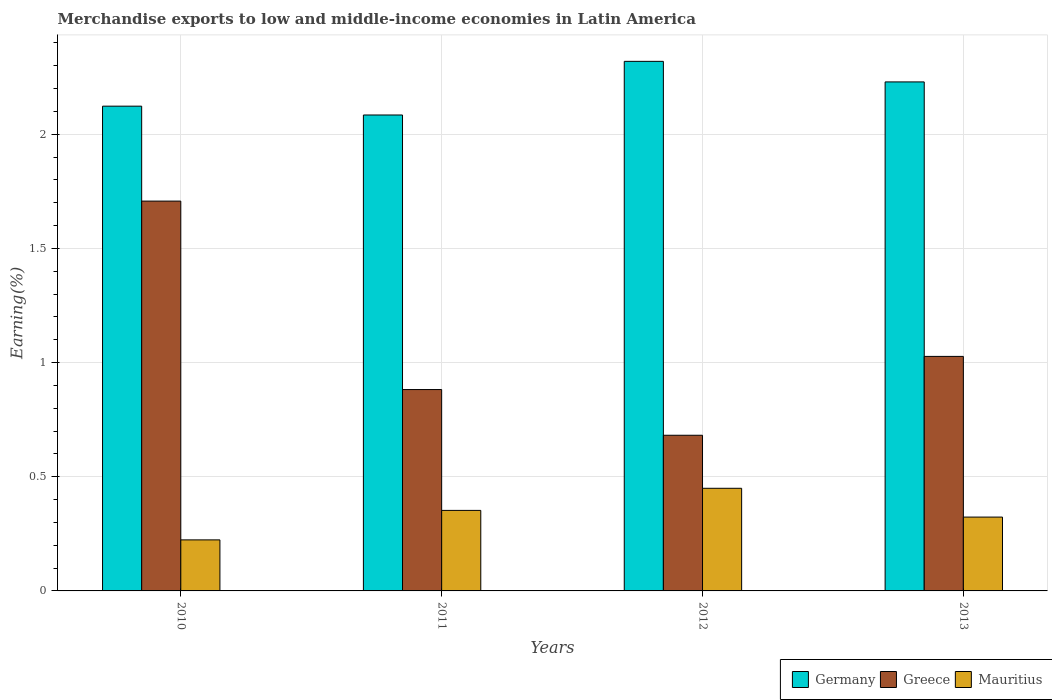How many different coloured bars are there?
Ensure brevity in your answer.  3. How many groups of bars are there?
Provide a succinct answer. 4. Are the number of bars on each tick of the X-axis equal?
Your answer should be compact. Yes. How many bars are there on the 2nd tick from the left?
Your answer should be compact. 3. In how many cases, is the number of bars for a given year not equal to the number of legend labels?
Give a very brief answer. 0. What is the percentage of amount earned from merchandise exports in Mauritius in 2011?
Offer a very short reply. 0.35. Across all years, what is the maximum percentage of amount earned from merchandise exports in Greece?
Offer a terse response. 1.71. Across all years, what is the minimum percentage of amount earned from merchandise exports in Mauritius?
Make the answer very short. 0.22. In which year was the percentage of amount earned from merchandise exports in Germany maximum?
Provide a short and direct response. 2012. In which year was the percentage of amount earned from merchandise exports in Germany minimum?
Give a very brief answer. 2011. What is the total percentage of amount earned from merchandise exports in Greece in the graph?
Keep it short and to the point. 4.3. What is the difference between the percentage of amount earned from merchandise exports in Mauritius in 2010 and that in 2011?
Provide a short and direct response. -0.13. What is the difference between the percentage of amount earned from merchandise exports in Germany in 2010 and the percentage of amount earned from merchandise exports in Mauritius in 2012?
Ensure brevity in your answer.  1.67. What is the average percentage of amount earned from merchandise exports in Germany per year?
Ensure brevity in your answer.  2.19. In the year 2011, what is the difference between the percentage of amount earned from merchandise exports in Mauritius and percentage of amount earned from merchandise exports in Germany?
Your response must be concise. -1.73. In how many years, is the percentage of amount earned from merchandise exports in Mauritius greater than 1.6 %?
Offer a very short reply. 0. What is the ratio of the percentage of amount earned from merchandise exports in Greece in 2011 to that in 2012?
Provide a short and direct response. 1.29. Is the percentage of amount earned from merchandise exports in Germany in 2011 less than that in 2012?
Provide a succinct answer. Yes. Is the difference between the percentage of amount earned from merchandise exports in Mauritius in 2011 and 2013 greater than the difference between the percentage of amount earned from merchandise exports in Germany in 2011 and 2013?
Your answer should be compact. Yes. What is the difference between the highest and the second highest percentage of amount earned from merchandise exports in Mauritius?
Provide a short and direct response. 0.1. What is the difference between the highest and the lowest percentage of amount earned from merchandise exports in Germany?
Make the answer very short. 0.23. What does the 2nd bar from the left in 2012 represents?
Your response must be concise. Greece. What does the 1st bar from the right in 2011 represents?
Make the answer very short. Mauritius. Is it the case that in every year, the sum of the percentage of amount earned from merchandise exports in Greece and percentage of amount earned from merchandise exports in Germany is greater than the percentage of amount earned from merchandise exports in Mauritius?
Keep it short and to the point. Yes. Are the values on the major ticks of Y-axis written in scientific E-notation?
Offer a terse response. No. Does the graph contain any zero values?
Offer a terse response. No. Where does the legend appear in the graph?
Your response must be concise. Bottom right. What is the title of the graph?
Your answer should be very brief. Merchandise exports to low and middle-income economies in Latin America. What is the label or title of the X-axis?
Provide a succinct answer. Years. What is the label or title of the Y-axis?
Provide a succinct answer. Earning(%). What is the Earning(%) in Germany in 2010?
Give a very brief answer. 2.12. What is the Earning(%) in Greece in 2010?
Make the answer very short. 1.71. What is the Earning(%) of Mauritius in 2010?
Your answer should be very brief. 0.22. What is the Earning(%) in Germany in 2011?
Your answer should be very brief. 2.08. What is the Earning(%) in Greece in 2011?
Provide a succinct answer. 0.88. What is the Earning(%) in Mauritius in 2011?
Your answer should be compact. 0.35. What is the Earning(%) in Germany in 2012?
Provide a short and direct response. 2.32. What is the Earning(%) in Greece in 2012?
Ensure brevity in your answer.  0.68. What is the Earning(%) in Mauritius in 2012?
Provide a succinct answer. 0.45. What is the Earning(%) of Germany in 2013?
Your answer should be compact. 2.23. What is the Earning(%) of Greece in 2013?
Provide a short and direct response. 1.03. What is the Earning(%) in Mauritius in 2013?
Provide a succinct answer. 0.32. Across all years, what is the maximum Earning(%) of Germany?
Offer a very short reply. 2.32. Across all years, what is the maximum Earning(%) in Greece?
Provide a short and direct response. 1.71. Across all years, what is the maximum Earning(%) in Mauritius?
Make the answer very short. 0.45. Across all years, what is the minimum Earning(%) of Germany?
Ensure brevity in your answer.  2.08. Across all years, what is the minimum Earning(%) in Greece?
Offer a terse response. 0.68. Across all years, what is the minimum Earning(%) of Mauritius?
Your answer should be very brief. 0.22. What is the total Earning(%) of Germany in the graph?
Keep it short and to the point. 8.75. What is the total Earning(%) of Greece in the graph?
Your answer should be very brief. 4.3. What is the total Earning(%) of Mauritius in the graph?
Your answer should be compact. 1.35. What is the difference between the Earning(%) of Germany in 2010 and that in 2011?
Make the answer very short. 0.04. What is the difference between the Earning(%) in Greece in 2010 and that in 2011?
Offer a very short reply. 0.83. What is the difference between the Earning(%) of Mauritius in 2010 and that in 2011?
Keep it short and to the point. -0.13. What is the difference between the Earning(%) of Germany in 2010 and that in 2012?
Your answer should be very brief. -0.2. What is the difference between the Earning(%) in Greece in 2010 and that in 2012?
Your response must be concise. 1.03. What is the difference between the Earning(%) in Mauritius in 2010 and that in 2012?
Your answer should be very brief. -0.23. What is the difference between the Earning(%) of Germany in 2010 and that in 2013?
Your answer should be very brief. -0.11. What is the difference between the Earning(%) in Greece in 2010 and that in 2013?
Your response must be concise. 0.68. What is the difference between the Earning(%) in Mauritius in 2010 and that in 2013?
Keep it short and to the point. -0.1. What is the difference between the Earning(%) in Germany in 2011 and that in 2012?
Ensure brevity in your answer.  -0.23. What is the difference between the Earning(%) in Greece in 2011 and that in 2012?
Offer a terse response. 0.2. What is the difference between the Earning(%) of Mauritius in 2011 and that in 2012?
Make the answer very short. -0.1. What is the difference between the Earning(%) in Germany in 2011 and that in 2013?
Your answer should be compact. -0.14. What is the difference between the Earning(%) of Greece in 2011 and that in 2013?
Offer a terse response. -0.15. What is the difference between the Earning(%) in Mauritius in 2011 and that in 2013?
Ensure brevity in your answer.  0.03. What is the difference between the Earning(%) in Germany in 2012 and that in 2013?
Offer a terse response. 0.09. What is the difference between the Earning(%) of Greece in 2012 and that in 2013?
Give a very brief answer. -0.35. What is the difference between the Earning(%) in Mauritius in 2012 and that in 2013?
Provide a succinct answer. 0.13. What is the difference between the Earning(%) of Germany in 2010 and the Earning(%) of Greece in 2011?
Provide a succinct answer. 1.24. What is the difference between the Earning(%) of Germany in 2010 and the Earning(%) of Mauritius in 2011?
Offer a terse response. 1.77. What is the difference between the Earning(%) in Greece in 2010 and the Earning(%) in Mauritius in 2011?
Provide a succinct answer. 1.35. What is the difference between the Earning(%) in Germany in 2010 and the Earning(%) in Greece in 2012?
Provide a succinct answer. 1.44. What is the difference between the Earning(%) of Germany in 2010 and the Earning(%) of Mauritius in 2012?
Provide a short and direct response. 1.67. What is the difference between the Earning(%) of Greece in 2010 and the Earning(%) of Mauritius in 2012?
Your answer should be compact. 1.26. What is the difference between the Earning(%) in Germany in 2010 and the Earning(%) in Greece in 2013?
Offer a terse response. 1.1. What is the difference between the Earning(%) of Germany in 2010 and the Earning(%) of Mauritius in 2013?
Offer a terse response. 1.8. What is the difference between the Earning(%) of Greece in 2010 and the Earning(%) of Mauritius in 2013?
Your answer should be compact. 1.38. What is the difference between the Earning(%) in Germany in 2011 and the Earning(%) in Greece in 2012?
Offer a terse response. 1.4. What is the difference between the Earning(%) in Germany in 2011 and the Earning(%) in Mauritius in 2012?
Your answer should be compact. 1.63. What is the difference between the Earning(%) in Greece in 2011 and the Earning(%) in Mauritius in 2012?
Ensure brevity in your answer.  0.43. What is the difference between the Earning(%) in Germany in 2011 and the Earning(%) in Greece in 2013?
Keep it short and to the point. 1.06. What is the difference between the Earning(%) in Germany in 2011 and the Earning(%) in Mauritius in 2013?
Keep it short and to the point. 1.76. What is the difference between the Earning(%) of Greece in 2011 and the Earning(%) of Mauritius in 2013?
Give a very brief answer. 0.56. What is the difference between the Earning(%) in Germany in 2012 and the Earning(%) in Greece in 2013?
Keep it short and to the point. 1.29. What is the difference between the Earning(%) in Germany in 2012 and the Earning(%) in Mauritius in 2013?
Your response must be concise. 2. What is the difference between the Earning(%) of Greece in 2012 and the Earning(%) of Mauritius in 2013?
Your response must be concise. 0.36. What is the average Earning(%) in Germany per year?
Provide a short and direct response. 2.19. What is the average Earning(%) of Greece per year?
Offer a terse response. 1.07. What is the average Earning(%) in Mauritius per year?
Make the answer very short. 0.34. In the year 2010, what is the difference between the Earning(%) in Germany and Earning(%) in Greece?
Your answer should be compact. 0.42. In the year 2010, what is the difference between the Earning(%) in Germany and Earning(%) in Mauritius?
Provide a short and direct response. 1.9. In the year 2010, what is the difference between the Earning(%) in Greece and Earning(%) in Mauritius?
Offer a very short reply. 1.48. In the year 2011, what is the difference between the Earning(%) of Germany and Earning(%) of Greece?
Provide a succinct answer. 1.2. In the year 2011, what is the difference between the Earning(%) in Germany and Earning(%) in Mauritius?
Your answer should be compact. 1.73. In the year 2011, what is the difference between the Earning(%) of Greece and Earning(%) of Mauritius?
Ensure brevity in your answer.  0.53. In the year 2012, what is the difference between the Earning(%) in Germany and Earning(%) in Greece?
Your answer should be compact. 1.64. In the year 2012, what is the difference between the Earning(%) in Germany and Earning(%) in Mauritius?
Keep it short and to the point. 1.87. In the year 2012, what is the difference between the Earning(%) in Greece and Earning(%) in Mauritius?
Your answer should be very brief. 0.23. In the year 2013, what is the difference between the Earning(%) of Germany and Earning(%) of Greece?
Your answer should be very brief. 1.2. In the year 2013, what is the difference between the Earning(%) in Germany and Earning(%) in Mauritius?
Give a very brief answer. 1.91. In the year 2013, what is the difference between the Earning(%) of Greece and Earning(%) of Mauritius?
Offer a very short reply. 0.7. What is the ratio of the Earning(%) in Germany in 2010 to that in 2011?
Ensure brevity in your answer.  1.02. What is the ratio of the Earning(%) in Greece in 2010 to that in 2011?
Keep it short and to the point. 1.94. What is the ratio of the Earning(%) in Mauritius in 2010 to that in 2011?
Your answer should be compact. 0.63. What is the ratio of the Earning(%) of Germany in 2010 to that in 2012?
Make the answer very short. 0.92. What is the ratio of the Earning(%) of Greece in 2010 to that in 2012?
Give a very brief answer. 2.5. What is the ratio of the Earning(%) of Mauritius in 2010 to that in 2012?
Offer a terse response. 0.5. What is the ratio of the Earning(%) in Germany in 2010 to that in 2013?
Your answer should be compact. 0.95. What is the ratio of the Earning(%) in Greece in 2010 to that in 2013?
Provide a succinct answer. 1.66. What is the ratio of the Earning(%) of Mauritius in 2010 to that in 2013?
Provide a succinct answer. 0.69. What is the ratio of the Earning(%) of Germany in 2011 to that in 2012?
Offer a terse response. 0.9. What is the ratio of the Earning(%) in Greece in 2011 to that in 2012?
Ensure brevity in your answer.  1.29. What is the ratio of the Earning(%) in Mauritius in 2011 to that in 2012?
Make the answer very short. 0.78. What is the ratio of the Earning(%) of Germany in 2011 to that in 2013?
Your answer should be compact. 0.94. What is the ratio of the Earning(%) of Greece in 2011 to that in 2013?
Provide a short and direct response. 0.86. What is the ratio of the Earning(%) of Mauritius in 2011 to that in 2013?
Provide a succinct answer. 1.09. What is the ratio of the Earning(%) in Germany in 2012 to that in 2013?
Give a very brief answer. 1.04. What is the ratio of the Earning(%) in Greece in 2012 to that in 2013?
Give a very brief answer. 0.66. What is the ratio of the Earning(%) in Mauritius in 2012 to that in 2013?
Make the answer very short. 1.39. What is the difference between the highest and the second highest Earning(%) of Germany?
Offer a terse response. 0.09. What is the difference between the highest and the second highest Earning(%) of Greece?
Offer a terse response. 0.68. What is the difference between the highest and the second highest Earning(%) in Mauritius?
Provide a succinct answer. 0.1. What is the difference between the highest and the lowest Earning(%) of Germany?
Offer a terse response. 0.23. What is the difference between the highest and the lowest Earning(%) in Greece?
Provide a short and direct response. 1.03. What is the difference between the highest and the lowest Earning(%) of Mauritius?
Provide a short and direct response. 0.23. 